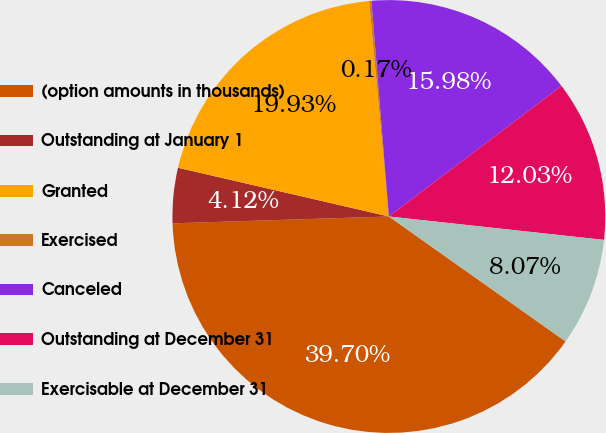<chart> <loc_0><loc_0><loc_500><loc_500><pie_chart><fcel>(option amounts in thousands)<fcel>Outstanding at January 1<fcel>Granted<fcel>Exercised<fcel>Canceled<fcel>Outstanding at December 31<fcel>Exercisable at December 31<nl><fcel>39.7%<fcel>4.12%<fcel>19.93%<fcel>0.17%<fcel>15.98%<fcel>12.03%<fcel>8.07%<nl></chart> 